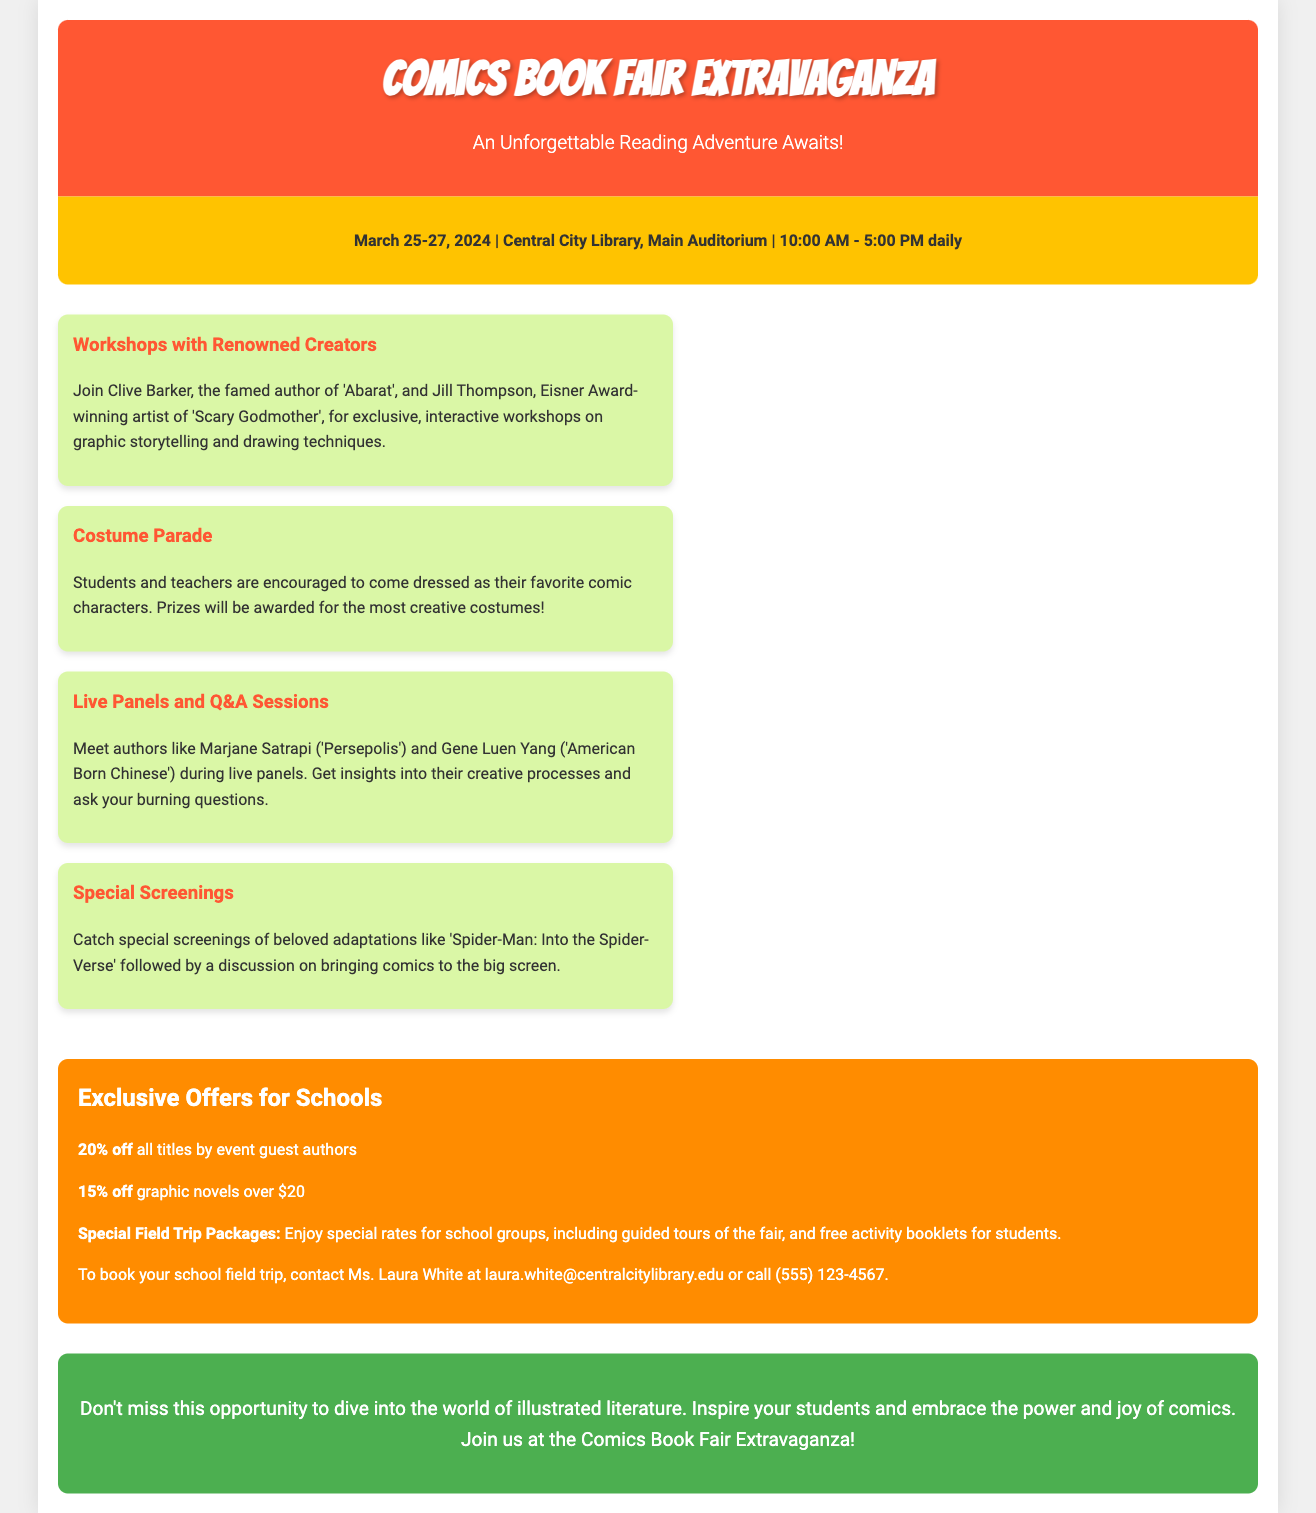What are the dates of the event? The event takes place from March 25 to March 27, 2024.
Answer: March 25-27, 2024 Who is one of the guest authors conducting workshops? Clive Barker is mentioned as one of the renowned creators leading workshops.
Answer: Clive Barker What type of event encourages students to dress up? The Costume Parade invites students and teachers to come dressed as their favorite comic characters.
Answer: Costume Parade What discount is offered on titles by event guest authors? There is a 20% discount on all titles by guest authors at the event.
Answer: 20% off What special arrangements are mentioned for school field trips? The document mentions special field trip packages that include guided tours and free activity booklets for students.
Answer: Special Field Trip Packages Which film will have a special screening at the fair? The event features a special screening of 'Spider-Man: Into the Spider-Verse'.
Answer: Spider-Man: Into the Spider-Verse What is the main theme of the event? The primary focus of the event is to engage students and teachers in the world of illustrated literature.
Answer: Illustrated Literature How can schools contact to book a field trip? Schools can contact Ms. Laura White via email or phone to book a field trip.
Answer: Ms. Laura White What is the venue for the event? The event will be held at the Central City Library, Main Auditorium.
Answer: Central City Library 